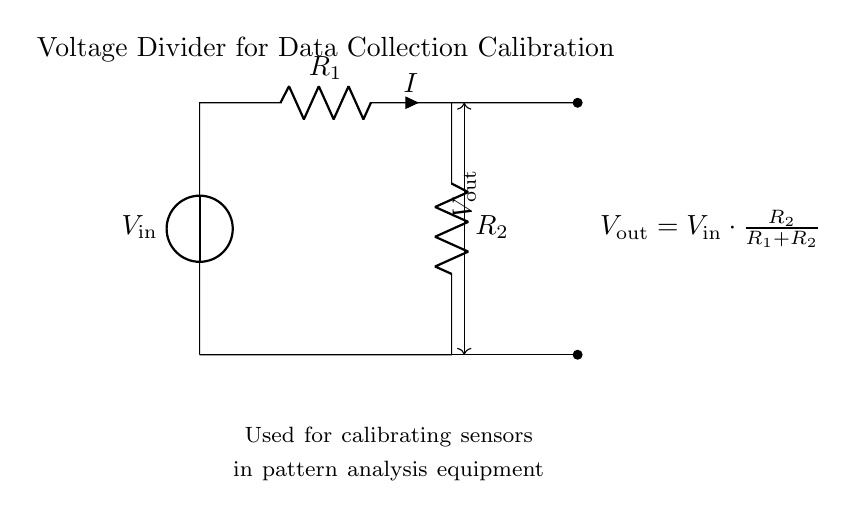What is the input voltage represented in the circuit? The input voltage, denoted as "V_in," is indicated by the voltage source symbol at the top of the circuit.
Answer: V_in What are the two resistors in the circuit labeled? The resistors are labeled as "R_1" and "R_2" on the diagram, showing their respective positions in the circuit.
Answer: R_1 and R_2 How is the output voltage calculated? The output voltage, "V_out," is calculated using the formula shown in the diagram: "V_out = V_in * R_2 / (R_1 + R_2)," which describes how it is derived from the input voltage and resistances.
Answer: V_out = V_in * R_2 / (R_1 + R_2) What type of circuit is depicted here? The diagram illustrates a voltage divider circuit, which is used to divide an input voltage into a lower output voltage.
Answer: Voltage divider Why is this circuit used for data collection calibration? This circuit is specifically designed to provide a precise output voltage level that can be used to calibrate sensors in data collection equipment, ensuring accurate measurements in pattern analysis.
Answer: Calibration What does the arrow indicate in the current direction? The arrow near the "I" label indicates the direction of current flow through the circuit, which is from "R_1" through "R_2" and then back to the voltage source.
Answer: Current direction 